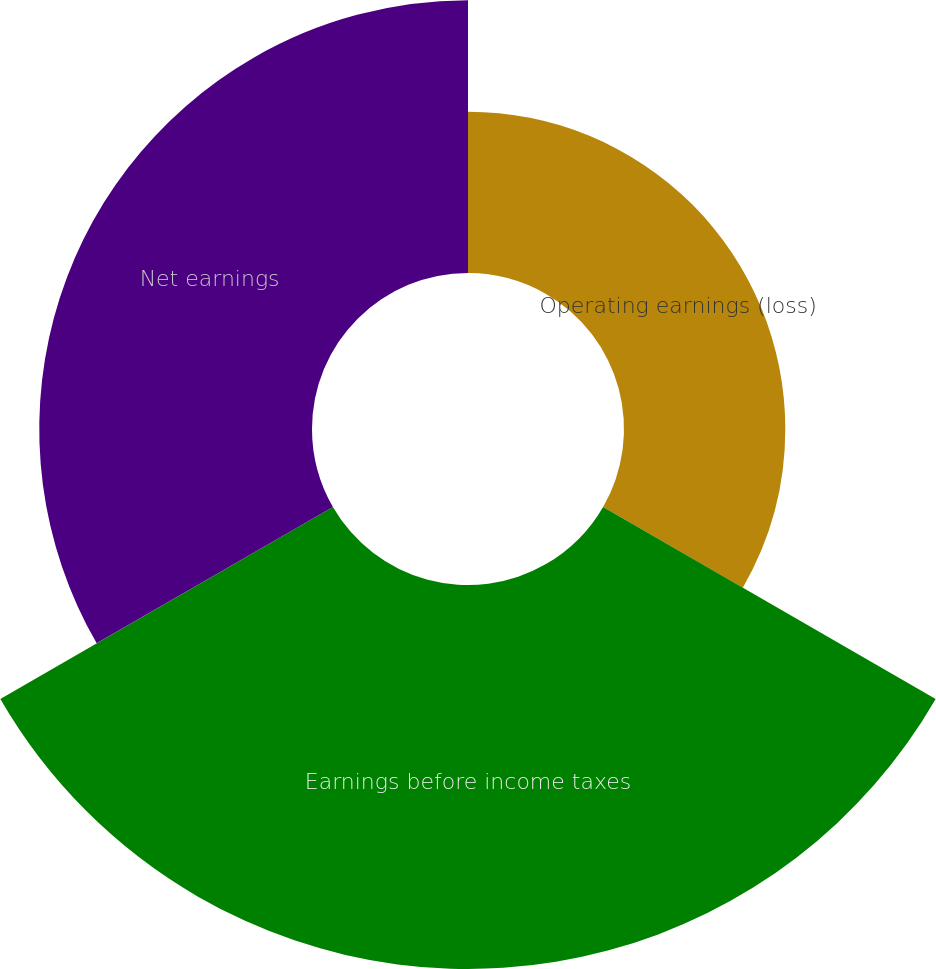Convert chart to OTSL. <chart><loc_0><loc_0><loc_500><loc_500><pie_chart><fcel>Operating earnings (loss)<fcel>Earnings before income taxes<fcel>Net earnings<nl><fcel>19.72%<fcel>46.94%<fcel>33.34%<nl></chart> 